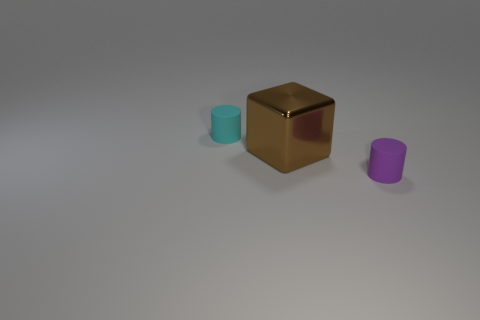Can you describe the texture of the objects displayed? Certainly! The cube in the image has a reflective and somewhat shiny texture, implying a metallic surface. The two cylinders, meanwhile, appear to have a matte texture that does not reflect light, suggesting they could be made of a plastic or non-metallic material. 